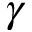Convert formula to latex. <formula><loc_0><loc_0><loc_500><loc_500>\gamma</formula> 